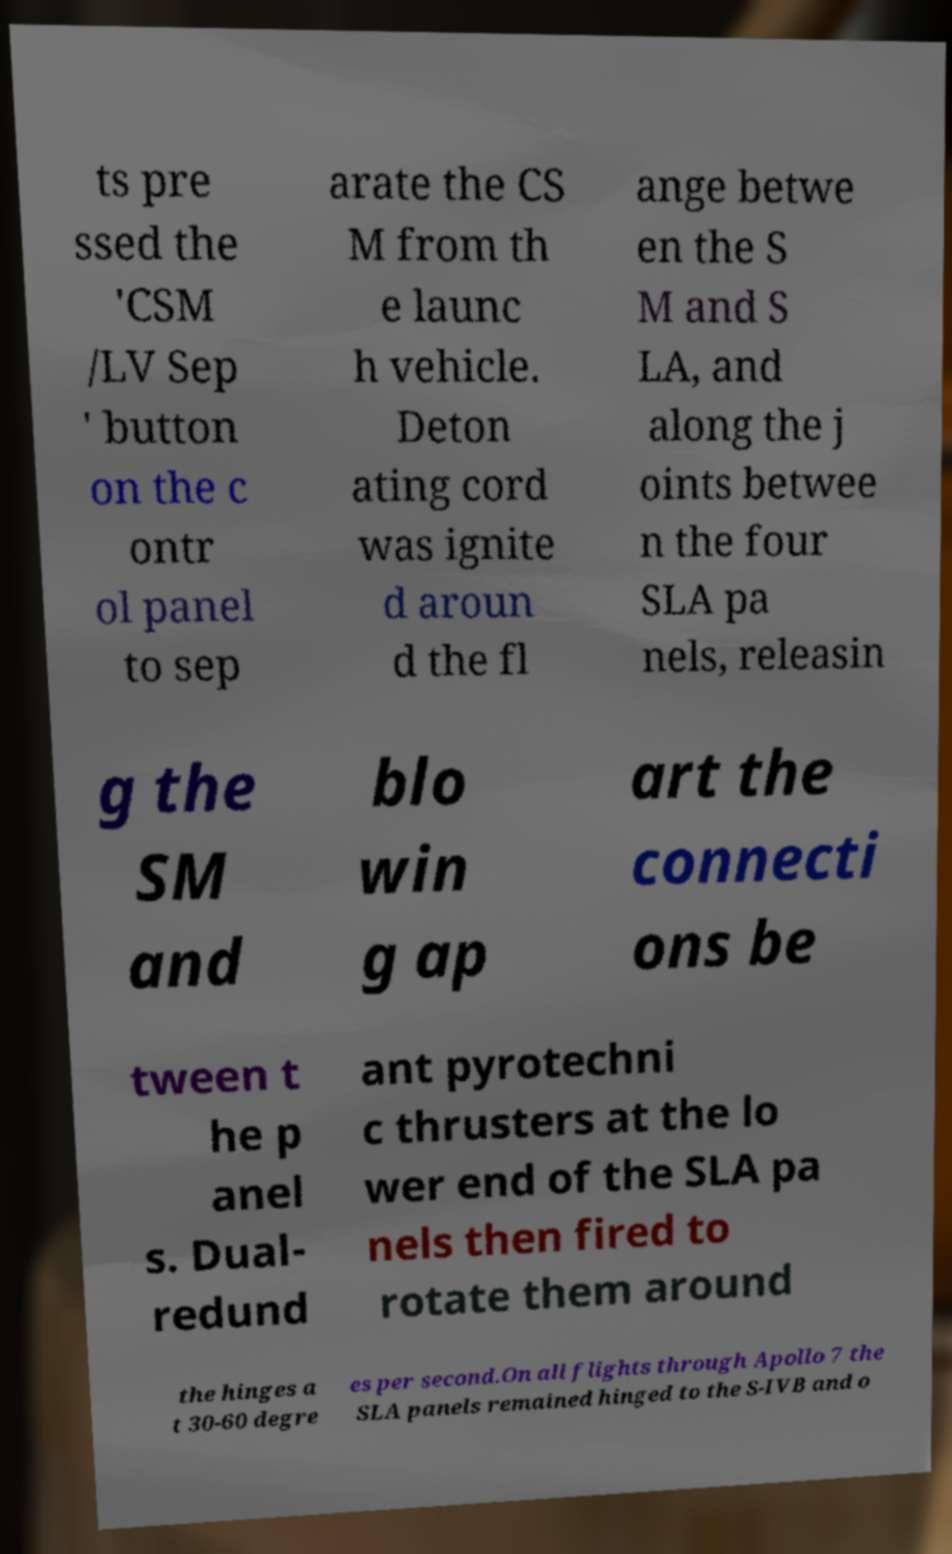Could you extract and type out the text from this image? ts pre ssed the 'CSM /LV Sep ' button on the c ontr ol panel to sep arate the CS M from th e launc h vehicle. Deton ating cord was ignite d aroun d the fl ange betwe en the S M and S LA, and along the j oints betwee n the four SLA pa nels, releasin g the SM and blo win g ap art the connecti ons be tween t he p anel s. Dual- redund ant pyrotechni c thrusters at the lo wer end of the SLA pa nels then fired to rotate them around the hinges a t 30-60 degre es per second.On all flights through Apollo 7 the SLA panels remained hinged to the S-IVB and o 